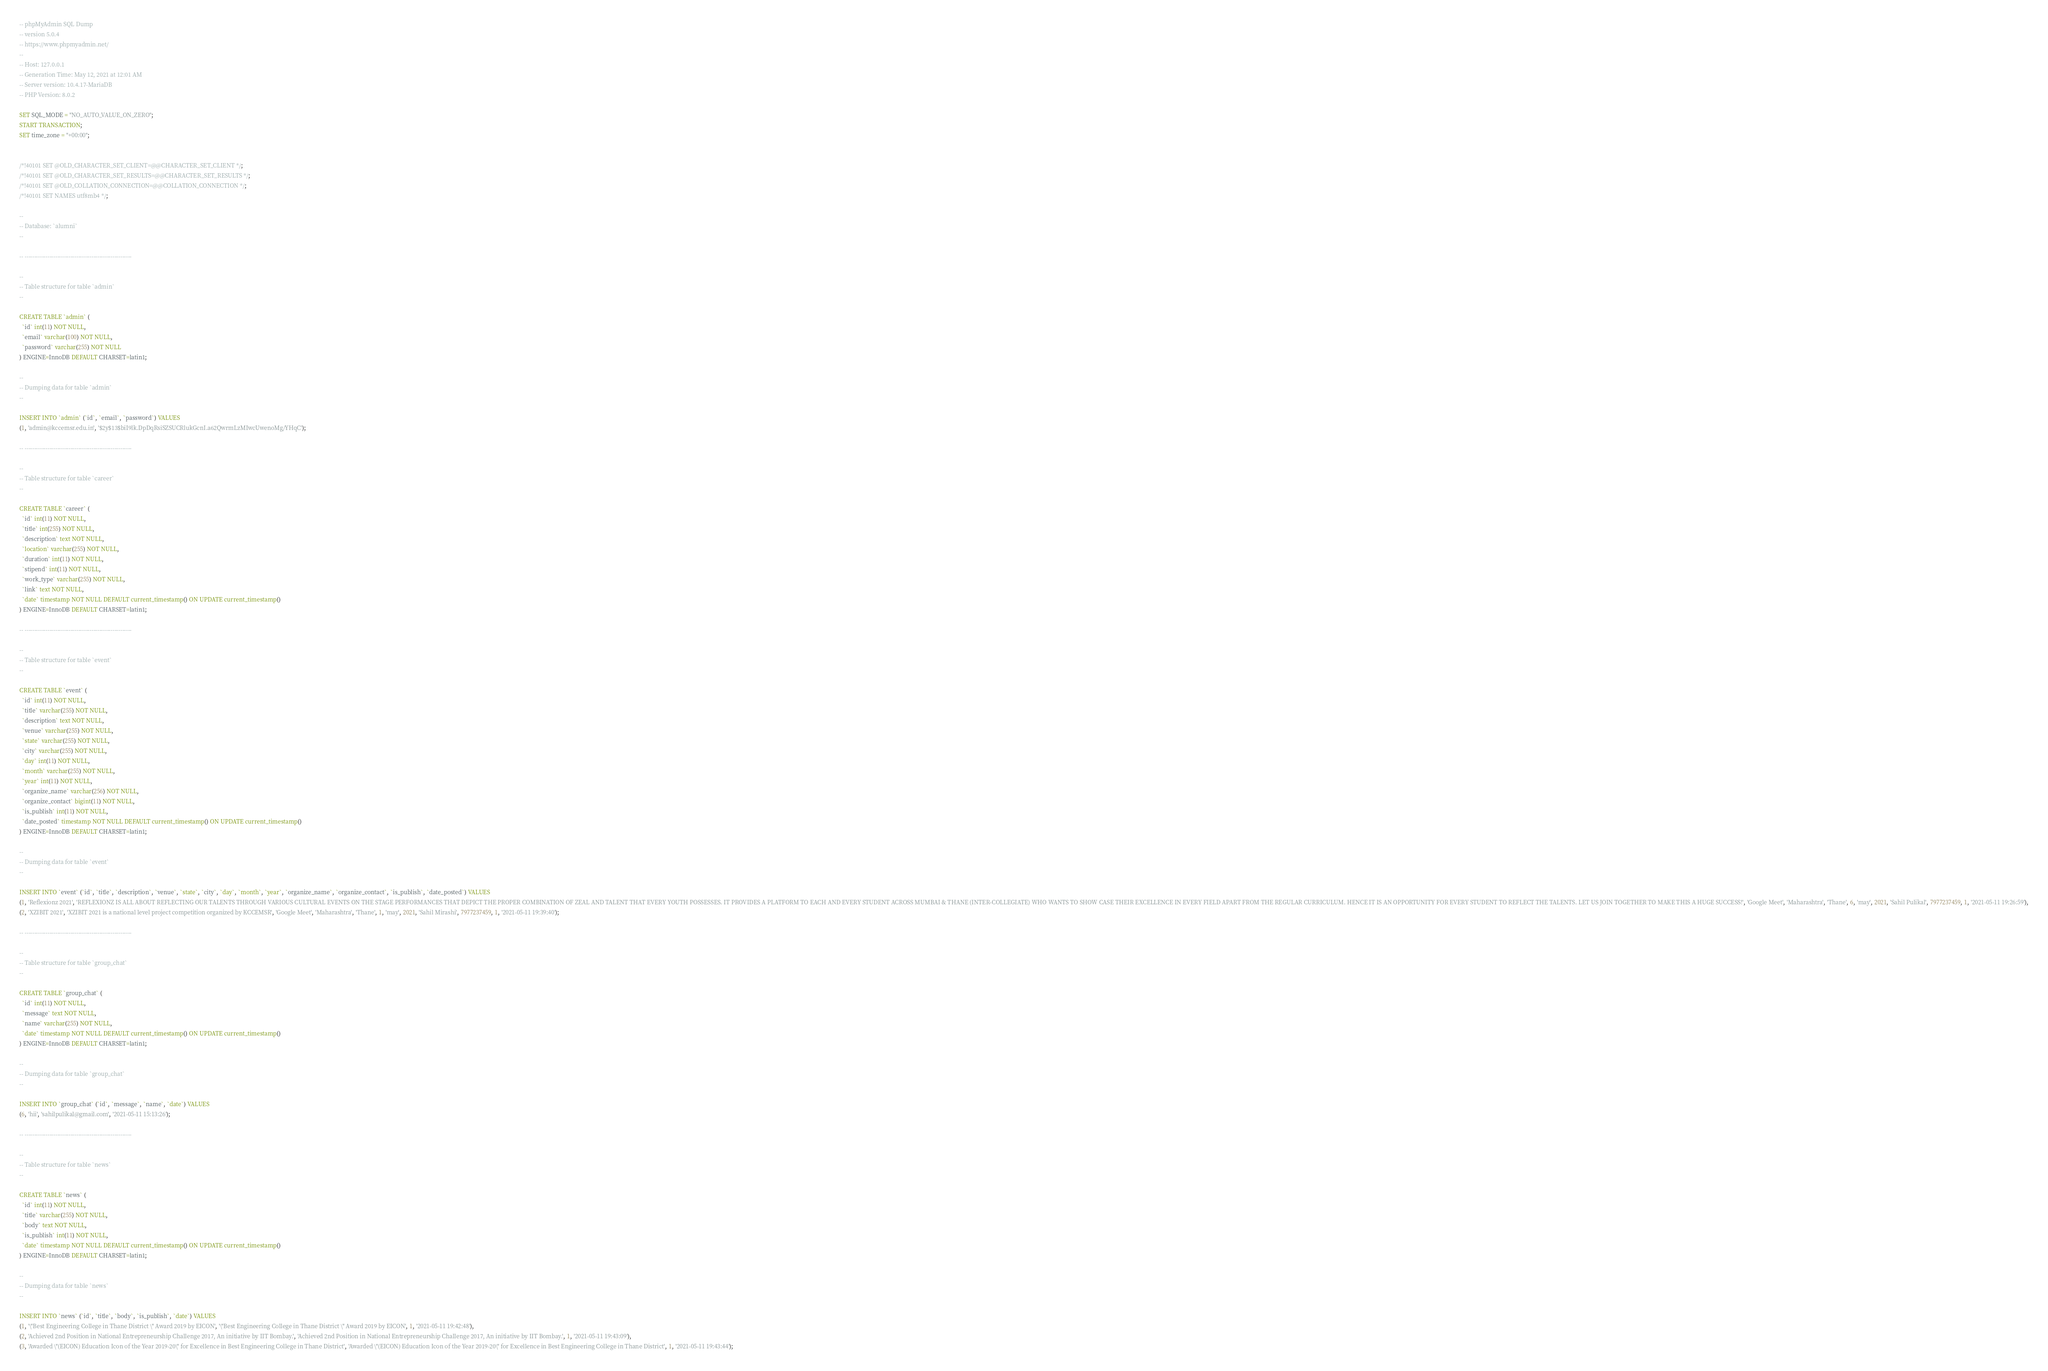Convert code to text. <code><loc_0><loc_0><loc_500><loc_500><_SQL_>-- phpMyAdmin SQL Dump
-- version 5.0.4
-- https://www.phpmyadmin.net/
--
-- Host: 127.0.0.1
-- Generation Time: May 12, 2021 at 12:01 AM
-- Server version: 10.4.17-MariaDB
-- PHP Version: 8.0.2

SET SQL_MODE = "NO_AUTO_VALUE_ON_ZERO";
START TRANSACTION;
SET time_zone = "+00:00";


/*!40101 SET @OLD_CHARACTER_SET_CLIENT=@@CHARACTER_SET_CLIENT */;
/*!40101 SET @OLD_CHARACTER_SET_RESULTS=@@CHARACTER_SET_RESULTS */;
/*!40101 SET @OLD_COLLATION_CONNECTION=@@COLLATION_CONNECTION */;
/*!40101 SET NAMES utf8mb4 */;

--
-- Database: `alumni`
--

-- --------------------------------------------------------

--
-- Table structure for table `admin`
--

CREATE TABLE `admin` (
  `id` int(11) NOT NULL,
  `email` varchar(100) NOT NULL,
  `password` varchar(255) NOT NULL
) ENGINE=InnoDB DEFAULT CHARSET=latin1;

--
-- Dumping data for table `admin`
--

INSERT INTO `admin` (`id`, `email`, `password`) VALUES
(1, 'admin@kccemsr.edu.in', '$2y$13$biI9lk.DpDqRsiSZSUCRlukGcnI.a62QwrmLzMIwcUwenoMg/YHqC');

-- --------------------------------------------------------

--
-- Table structure for table `career`
--

CREATE TABLE `career` (
  `id` int(11) NOT NULL,
  `title` int(255) NOT NULL,
  `description` text NOT NULL,
  `location` varchar(255) NOT NULL,
  `duration` int(11) NOT NULL,
  `stipend` int(11) NOT NULL,
  `work_type` varchar(255) NOT NULL,
  `link` text NOT NULL,
  `date` timestamp NOT NULL DEFAULT current_timestamp() ON UPDATE current_timestamp()
) ENGINE=InnoDB DEFAULT CHARSET=latin1;

-- --------------------------------------------------------

--
-- Table structure for table `event`
--

CREATE TABLE `event` (
  `id` int(11) NOT NULL,
  `title` varchar(255) NOT NULL,
  `description` text NOT NULL,
  `venue` varchar(255) NOT NULL,
  `state` varchar(255) NOT NULL,
  `city` varchar(255) NOT NULL,
  `day` int(11) NOT NULL,
  `month` varchar(255) NOT NULL,
  `year` int(11) NOT NULL,
  `organize_name` varchar(256) NOT NULL,
  `organize_contact` bigint(11) NOT NULL,
  `is_publish` int(11) NOT NULL,
  `date_posted` timestamp NOT NULL DEFAULT current_timestamp() ON UPDATE current_timestamp()
) ENGINE=InnoDB DEFAULT CHARSET=latin1;

--
-- Dumping data for table `event`
--

INSERT INTO `event` (`id`, `title`, `description`, `venue`, `state`, `city`, `day`, `month`, `year`, `organize_name`, `organize_contact`, `is_publish`, `date_posted`) VALUES
(1, 'Reflexionz 2021', 'REFLEXIONZ IS ALL ABOUT REFLECTING OUR TALENTS THROUGH VARIOUS CULTURAL EVENTS ON THE STAGE PERFORMANCES THAT DEPICT THE PROPER COMBINATION OF ZEAL AND TALENT THAT EVERY YOUTH POSSESSES. IT PROVIDES A PLATFORM TO EACH AND EVERY STUDENT ACROSS MUMBAI & THANE (INTER-COLLEGIATE) WHO WANTS TO SHOW CASE THEIR EXCELLENCE IN EVERY FIELD APART FROM THE REGULAR CURRICULUM. HENCE IT IS AN OPPORTUNITY FOR EVERY STUDENT TO REFLECT THE TALENTS. LET US JOIN TOGETHER TO MAKE THIS A HUGE SUCCESS!', 'Google Meet', 'Maharashtra', 'Thane', 6, 'may', 2021, 'Sahil Pulikal', 7977237459, 1, '2021-05-11 19:26:59'),
(2, 'XZIBIT 2021', 'XZIBIT 2021 is a national level project competition organized by KCCEMSR', 'Google Meet', 'Maharashtra', 'Thane', 1, 'may', 2021, 'Sahil Mirashi', 7977237459, 1, '2021-05-11 19:39:40');

-- --------------------------------------------------------

--
-- Table structure for table `group_chat`
--

CREATE TABLE `group_chat` (
  `id` int(11) NOT NULL,
  `message` text NOT NULL,
  `name` varchar(255) NOT NULL,
  `date` timestamp NOT NULL DEFAULT current_timestamp() ON UPDATE current_timestamp()
) ENGINE=InnoDB DEFAULT CHARSET=latin1;

--
-- Dumping data for table `group_chat`
--

INSERT INTO `group_chat` (`id`, `message`, `name`, `date`) VALUES
(6, 'hii', 'sahilpulikal@gmail.com', '2021-05-11 15:13:26');

-- --------------------------------------------------------

--
-- Table structure for table `news`
--

CREATE TABLE `news` (
  `id` int(11) NOT NULL,
  `title` varchar(255) NOT NULL,
  `body` text NOT NULL,
  `is_publish` int(11) NOT NULL,
  `date` timestamp NOT NULL DEFAULT current_timestamp() ON UPDATE current_timestamp()
) ENGINE=InnoDB DEFAULT CHARSET=latin1;

--
-- Dumping data for table `news`
--

INSERT INTO `news` (`id`, `title`, `body`, `is_publish`, `date`) VALUES
(1, '\"Best Engineering College in Thane District \" Award 2019 by EICON', '\"Best Engineering College in Thane District \" Award 2019 by EICON', 1, '2021-05-11 19:42:48'),
(2, 'Achieved 2nd Position in National Entrepreneurship Challenge 2017, An initiative by IIT Bombay.', 'Achieved 2nd Position in National Entrepreneurship Challenge 2017, An initiative by IIT Bombay.', 1, '2021-05-11 19:43:09'),
(3, 'Awarded \"(EICON) Education Icon of the Year 2019-20\" for Excellence in Best Engineering College in Thane District', 'Awarded \"(EICON) Education Icon of the Year 2019-20\" for Excellence in Best Engineering College in Thane District', 1, '2021-05-11 19:43:44');
</code> 